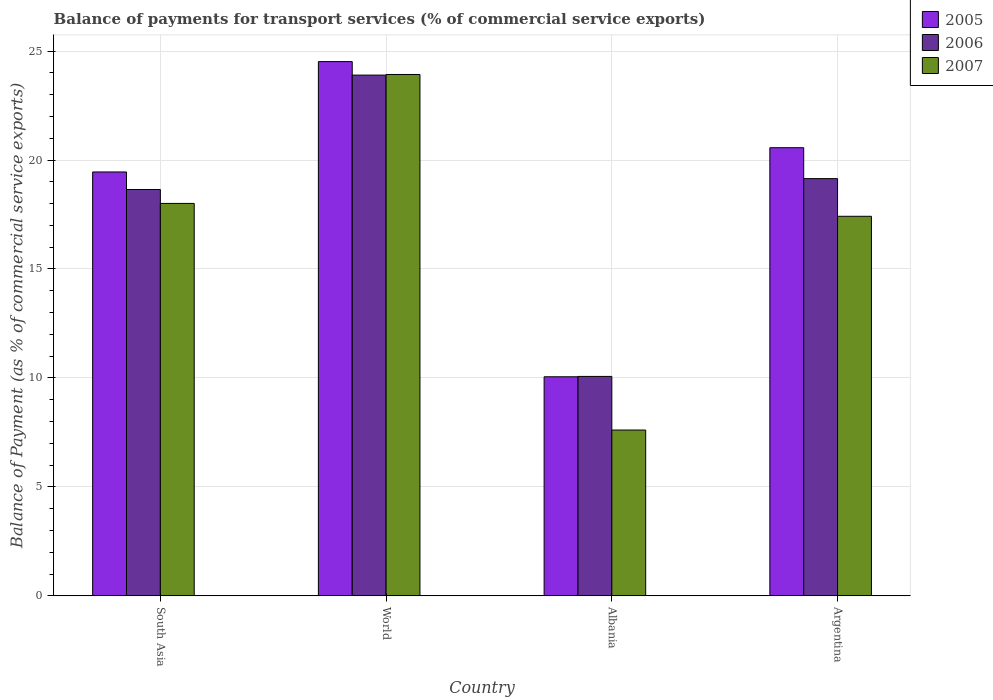How many groups of bars are there?
Offer a terse response. 4. Are the number of bars per tick equal to the number of legend labels?
Offer a terse response. Yes. Are the number of bars on each tick of the X-axis equal?
Offer a very short reply. Yes. What is the balance of payments for transport services in 2005 in South Asia?
Keep it short and to the point. 19.45. Across all countries, what is the maximum balance of payments for transport services in 2007?
Keep it short and to the point. 23.93. Across all countries, what is the minimum balance of payments for transport services in 2006?
Your response must be concise. 10.07. In which country was the balance of payments for transport services in 2006 maximum?
Provide a short and direct response. World. In which country was the balance of payments for transport services in 2007 minimum?
Your response must be concise. Albania. What is the total balance of payments for transport services in 2007 in the graph?
Your answer should be very brief. 66.96. What is the difference between the balance of payments for transport services in 2007 in South Asia and that in World?
Your answer should be compact. -5.92. What is the difference between the balance of payments for transport services in 2006 in Albania and the balance of payments for transport services in 2007 in Argentina?
Offer a very short reply. -7.35. What is the average balance of payments for transport services in 2007 per country?
Provide a succinct answer. 16.74. What is the difference between the balance of payments for transport services of/in 2007 and balance of payments for transport services of/in 2005 in South Asia?
Ensure brevity in your answer.  -1.44. What is the ratio of the balance of payments for transport services in 2006 in Albania to that in World?
Offer a terse response. 0.42. What is the difference between the highest and the second highest balance of payments for transport services in 2007?
Give a very brief answer. -0.59. What is the difference between the highest and the lowest balance of payments for transport services in 2006?
Offer a very short reply. 13.83. What does the 3rd bar from the left in World represents?
Provide a short and direct response. 2007. What does the 3rd bar from the right in South Asia represents?
Ensure brevity in your answer.  2005. How many bars are there?
Your response must be concise. 12. Are all the bars in the graph horizontal?
Give a very brief answer. No. What is the difference between two consecutive major ticks on the Y-axis?
Offer a terse response. 5. Are the values on the major ticks of Y-axis written in scientific E-notation?
Offer a very short reply. No. Does the graph contain any zero values?
Give a very brief answer. No. Where does the legend appear in the graph?
Give a very brief answer. Top right. How many legend labels are there?
Keep it short and to the point. 3. What is the title of the graph?
Your answer should be very brief. Balance of payments for transport services (% of commercial service exports). What is the label or title of the X-axis?
Offer a terse response. Country. What is the label or title of the Y-axis?
Make the answer very short. Balance of Payment (as % of commercial service exports). What is the Balance of Payment (as % of commercial service exports) in 2005 in South Asia?
Provide a succinct answer. 19.45. What is the Balance of Payment (as % of commercial service exports) of 2006 in South Asia?
Keep it short and to the point. 18.65. What is the Balance of Payment (as % of commercial service exports) of 2007 in South Asia?
Keep it short and to the point. 18.01. What is the Balance of Payment (as % of commercial service exports) of 2005 in World?
Your response must be concise. 24.52. What is the Balance of Payment (as % of commercial service exports) of 2006 in World?
Offer a terse response. 23.9. What is the Balance of Payment (as % of commercial service exports) in 2007 in World?
Offer a terse response. 23.93. What is the Balance of Payment (as % of commercial service exports) in 2005 in Albania?
Your answer should be very brief. 10.05. What is the Balance of Payment (as % of commercial service exports) of 2006 in Albania?
Keep it short and to the point. 10.07. What is the Balance of Payment (as % of commercial service exports) of 2007 in Albania?
Provide a succinct answer. 7.61. What is the Balance of Payment (as % of commercial service exports) in 2005 in Argentina?
Your answer should be compact. 20.57. What is the Balance of Payment (as % of commercial service exports) in 2006 in Argentina?
Ensure brevity in your answer.  19.15. What is the Balance of Payment (as % of commercial service exports) of 2007 in Argentina?
Your answer should be compact. 17.42. Across all countries, what is the maximum Balance of Payment (as % of commercial service exports) of 2005?
Give a very brief answer. 24.52. Across all countries, what is the maximum Balance of Payment (as % of commercial service exports) of 2006?
Your response must be concise. 23.9. Across all countries, what is the maximum Balance of Payment (as % of commercial service exports) in 2007?
Ensure brevity in your answer.  23.93. Across all countries, what is the minimum Balance of Payment (as % of commercial service exports) of 2005?
Give a very brief answer. 10.05. Across all countries, what is the minimum Balance of Payment (as % of commercial service exports) in 2006?
Your response must be concise. 10.07. Across all countries, what is the minimum Balance of Payment (as % of commercial service exports) in 2007?
Your answer should be compact. 7.61. What is the total Balance of Payment (as % of commercial service exports) in 2005 in the graph?
Provide a succinct answer. 74.59. What is the total Balance of Payment (as % of commercial service exports) in 2006 in the graph?
Provide a short and direct response. 71.76. What is the total Balance of Payment (as % of commercial service exports) of 2007 in the graph?
Make the answer very short. 66.96. What is the difference between the Balance of Payment (as % of commercial service exports) of 2005 in South Asia and that in World?
Give a very brief answer. -5.07. What is the difference between the Balance of Payment (as % of commercial service exports) in 2006 in South Asia and that in World?
Offer a terse response. -5.25. What is the difference between the Balance of Payment (as % of commercial service exports) in 2007 in South Asia and that in World?
Give a very brief answer. -5.92. What is the difference between the Balance of Payment (as % of commercial service exports) of 2005 in South Asia and that in Albania?
Your answer should be very brief. 9.4. What is the difference between the Balance of Payment (as % of commercial service exports) of 2006 in South Asia and that in Albania?
Provide a succinct answer. 8.58. What is the difference between the Balance of Payment (as % of commercial service exports) of 2007 in South Asia and that in Albania?
Make the answer very short. 10.4. What is the difference between the Balance of Payment (as % of commercial service exports) of 2005 in South Asia and that in Argentina?
Your answer should be compact. -1.11. What is the difference between the Balance of Payment (as % of commercial service exports) in 2006 in South Asia and that in Argentina?
Make the answer very short. -0.5. What is the difference between the Balance of Payment (as % of commercial service exports) in 2007 in South Asia and that in Argentina?
Offer a terse response. 0.59. What is the difference between the Balance of Payment (as % of commercial service exports) in 2005 in World and that in Albania?
Make the answer very short. 14.46. What is the difference between the Balance of Payment (as % of commercial service exports) in 2006 in World and that in Albania?
Offer a terse response. 13.83. What is the difference between the Balance of Payment (as % of commercial service exports) of 2007 in World and that in Albania?
Your response must be concise. 16.32. What is the difference between the Balance of Payment (as % of commercial service exports) in 2005 in World and that in Argentina?
Keep it short and to the point. 3.95. What is the difference between the Balance of Payment (as % of commercial service exports) in 2006 in World and that in Argentina?
Your answer should be very brief. 4.75. What is the difference between the Balance of Payment (as % of commercial service exports) in 2007 in World and that in Argentina?
Offer a terse response. 6.51. What is the difference between the Balance of Payment (as % of commercial service exports) in 2005 in Albania and that in Argentina?
Offer a very short reply. -10.51. What is the difference between the Balance of Payment (as % of commercial service exports) of 2006 in Albania and that in Argentina?
Provide a succinct answer. -9.08. What is the difference between the Balance of Payment (as % of commercial service exports) of 2007 in Albania and that in Argentina?
Ensure brevity in your answer.  -9.81. What is the difference between the Balance of Payment (as % of commercial service exports) in 2005 in South Asia and the Balance of Payment (as % of commercial service exports) in 2006 in World?
Offer a terse response. -4.45. What is the difference between the Balance of Payment (as % of commercial service exports) in 2005 in South Asia and the Balance of Payment (as % of commercial service exports) in 2007 in World?
Provide a succinct answer. -4.47. What is the difference between the Balance of Payment (as % of commercial service exports) of 2006 in South Asia and the Balance of Payment (as % of commercial service exports) of 2007 in World?
Offer a very short reply. -5.28. What is the difference between the Balance of Payment (as % of commercial service exports) of 2005 in South Asia and the Balance of Payment (as % of commercial service exports) of 2006 in Albania?
Offer a terse response. 9.38. What is the difference between the Balance of Payment (as % of commercial service exports) in 2005 in South Asia and the Balance of Payment (as % of commercial service exports) in 2007 in Albania?
Keep it short and to the point. 11.84. What is the difference between the Balance of Payment (as % of commercial service exports) of 2006 in South Asia and the Balance of Payment (as % of commercial service exports) of 2007 in Albania?
Offer a terse response. 11.04. What is the difference between the Balance of Payment (as % of commercial service exports) in 2005 in South Asia and the Balance of Payment (as % of commercial service exports) in 2006 in Argentina?
Keep it short and to the point. 0.31. What is the difference between the Balance of Payment (as % of commercial service exports) of 2005 in South Asia and the Balance of Payment (as % of commercial service exports) of 2007 in Argentina?
Provide a short and direct response. 2.03. What is the difference between the Balance of Payment (as % of commercial service exports) of 2006 in South Asia and the Balance of Payment (as % of commercial service exports) of 2007 in Argentina?
Provide a short and direct response. 1.23. What is the difference between the Balance of Payment (as % of commercial service exports) in 2005 in World and the Balance of Payment (as % of commercial service exports) in 2006 in Albania?
Provide a succinct answer. 14.45. What is the difference between the Balance of Payment (as % of commercial service exports) in 2005 in World and the Balance of Payment (as % of commercial service exports) in 2007 in Albania?
Give a very brief answer. 16.91. What is the difference between the Balance of Payment (as % of commercial service exports) in 2006 in World and the Balance of Payment (as % of commercial service exports) in 2007 in Albania?
Provide a succinct answer. 16.29. What is the difference between the Balance of Payment (as % of commercial service exports) in 2005 in World and the Balance of Payment (as % of commercial service exports) in 2006 in Argentina?
Your response must be concise. 5.37. What is the difference between the Balance of Payment (as % of commercial service exports) in 2005 in World and the Balance of Payment (as % of commercial service exports) in 2007 in Argentina?
Offer a very short reply. 7.1. What is the difference between the Balance of Payment (as % of commercial service exports) in 2006 in World and the Balance of Payment (as % of commercial service exports) in 2007 in Argentina?
Ensure brevity in your answer.  6.48. What is the difference between the Balance of Payment (as % of commercial service exports) of 2005 in Albania and the Balance of Payment (as % of commercial service exports) of 2006 in Argentina?
Offer a very short reply. -9.09. What is the difference between the Balance of Payment (as % of commercial service exports) in 2005 in Albania and the Balance of Payment (as % of commercial service exports) in 2007 in Argentina?
Offer a terse response. -7.37. What is the difference between the Balance of Payment (as % of commercial service exports) in 2006 in Albania and the Balance of Payment (as % of commercial service exports) in 2007 in Argentina?
Offer a terse response. -7.35. What is the average Balance of Payment (as % of commercial service exports) in 2005 per country?
Offer a very short reply. 18.65. What is the average Balance of Payment (as % of commercial service exports) of 2006 per country?
Offer a terse response. 17.94. What is the average Balance of Payment (as % of commercial service exports) of 2007 per country?
Offer a very short reply. 16.74. What is the difference between the Balance of Payment (as % of commercial service exports) of 2005 and Balance of Payment (as % of commercial service exports) of 2006 in South Asia?
Your answer should be compact. 0.8. What is the difference between the Balance of Payment (as % of commercial service exports) in 2005 and Balance of Payment (as % of commercial service exports) in 2007 in South Asia?
Ensure brevity in your answer.  1.44. What is the difference between the Balance of Payment (as % of commercial service exports) in 2006 and Balance of Payment (as % of commercial service exports) in 2007 in South Asia?
Your answer should be very brief. 0.64. What is the difference between the Balance of Payment (as % of commercial service exports) of 2005 and Balance of Payment (as % of commercial service exports) of 2006 in World?
Your answer should be compact. 0.62. What is the difference between the Balance of Payment (as % of commercial service exports) of 2005 and Balance of Payment (as % of commercial service exports) of 2007 in World?
Provide a succinct answer. 0.59. What is the difference between the Balance of Payment (as % of commercial service exports) in 2006 and Balance of Payment (as % of commercial service exports) in 2007 in World?
Provide a succinct answer. -0.03. What is the difference between the Balance of Payment (as % of commercial service exports) in 2005 and Balance of Payment (as % of commercial service exports) in 2006 in Albania?
Your response must be concise. -0.02. What is the difference between the Balance of Payment (as % of commercial service exports) in 2005 and Balance of Payment (as % of commercial service exports) in 2007 in Albania?
Your answer should be very brief. 2.44. What is the difference between the Balance of Payment (as % of commercial service exports) in 2006 and Balance of Payment (as % of commercial service exports) in 2007 in Albania?
Make the answer very short. 2.46. What is the difference between the Balance of Payment (as % of commercial service exports) of 2005 and Balance of Payment (as % of commercial service exports) of 2006 in Argentina?
Make the answer very short. 1.42. What is the difference between the Balance of Payment (as % of commercial service exports) in 2005 and Balance of Payment (as % of commercial service exports) in 2007 in Argentina?
Your response must be concise. 3.15. What is the difference between the Balance of Payment (as % of commercial service exports) of 2006 and Balance of Payment (as % of commercial service exports) of 2007 in Argentina?
Provide a succinct answer. 1.73. What is the ratio of the Balance of Payment (as % of commercial service exports) in 2005 in South Asia to that in World?
Offer a very short reply. 0.79. What is the ratio of the Balance of Payment (as % of commercial service exports) in 2006 in South Asia to that in World?
Provide a succinct answer. 0.78. What is the ratio of the Balance of Payment (as % of commercial service exports) of 2007 in South Asia to that in World?
Your answer should be compact. 0.75. What is the ratio of the Balance of Payment (as % of commercial service exports) in 2005 in South Asia to that in Albania?
Offer a very short reply. 1.94. What is the ratio of the Balance of Payment (as % of commercial service exports) in 2006 in South Asia to that in Albania?
Offer a terse response. 1.85. What is the ratio of the Balance of Payment (as % of commercial service exports) in 2007 in South Asia to that in Albania?
Your response must be concise. 2.37. What is the ratio of the Balance of Payment (as % of commercial service exports) in 2005 in South Asia to that in Argentina?
Your answer should be very brief. 0.95. What is the ratio of the Balance of Payment (as % of commercial service exports) in 2006 in South Asia to that in Argentina?
Offer a very short reply. 0.97. What is the ratio of the Balance of Payment (as % of commercial service exports) in 2007 in South Asia to that in Argentina?
Offer a very short reply. 1.03. What is the ratio of the Balance of Payment (as % of commercial service exports) in 2005 in World to that in Albania?
Your answer should be compact. 2.44. What is the ratio of the Balance of Payment (as % of commercial service exports) in 2006 in World to that in Albania?
Offer a very short reply. 2.37. What is the ratio of the Balance of Payment (as % of commercial service exports) in 2007 in World to that in Albania?
Ensure brevity in your answer.  3.14. What is the ratio of the Balance of Payment (as % of commercial service exports) in 2005 in World to that in Argentina?
Offer a terse response. 1.19. What is the ratio of the Balance of Payment (as % of commercial service exports) in 2006 in World to that in Argentina?
Give a very brief answer. 1.25. What is the ratio of the Balance of Payment (as % of commercial service exports) of 2007 in World to that in Argentina?
Offer a terse response. 1.37. What is the ratio of the Balance of Payment (as % of commercial service exports) of 2005 in Albania to that in Argentina?
Your response must be concise. 0.49. What is the ratio of the Balance of Payment (as % of commercial service exports) of 2006 in Albania to that in Argentina?
Offer a very short reply. 0.53. What is the ratio of the Balance of Payment (as % of commercial service exports) of 2007 in Albania to that in Argentina?
Offer a terse response. 0.44. What is the difference between the highest and the second highest Balance of Payment (as % of commercial service exports) of 2005?
Ensure brevity in your answer.  3.95. What is the difference between the highest and the second highest Balance of Payment (as % of commercial service exports) of 2006?
Ensure brevity in your answer.  4.75. What is the difference between the highest and the second highest Balance of Payment (as % of commercial service exports) of 2007?
Give a very brief answer. 5.92. What is the difference between the highest and the lowest Balance of Payment (as % of commercial service exports) of 2005?
Keep it short and to the point. 14.46. What is the difference between the highest and the lowest Balance of Payment (as % of commercial service exports) of 2006?
Your answer should be very brief. 13.83. What is the difference between the highest and the lowest Balance of Payment (as % of commercial service exports) in 2007?
Make the answer very short. 16.32. 